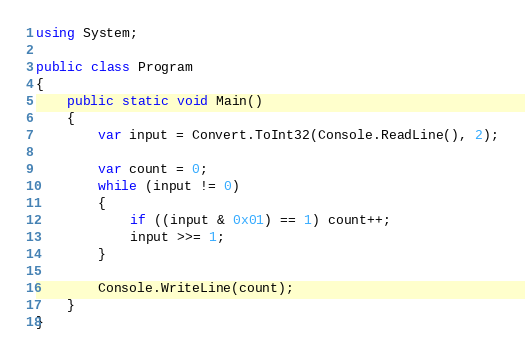Convert code to text. <code><loc_0><loc_0><loc_500><loc_500><_C#_>using System;

public class Program
{
	public static void Main()
	{
        var input = Convert.ToInt32(Console.ReadLine(), 2);

        var count = 0;
        while (input != 0)
        {
            if ((input & 0x01) == 1) count++;
            input >>= 1;
        }

        Console.WriteLine(count);
	}
}
</code> 